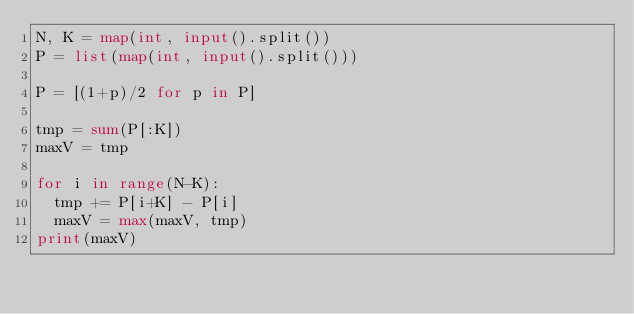<code> <loc_0><loc_0><loc_500><loc_500><_Python_>N, K = map(int, input().split())
P = list(map(int, input().split()))

P = [(1+p)/2 for p in P]

tmp = sum(P[:K])
maxV = tmp

for i in range(N-K):
  tmp += P[i+K] - P[i]
  maxV = max(maxV, tmp)
print(maxV)</code> 